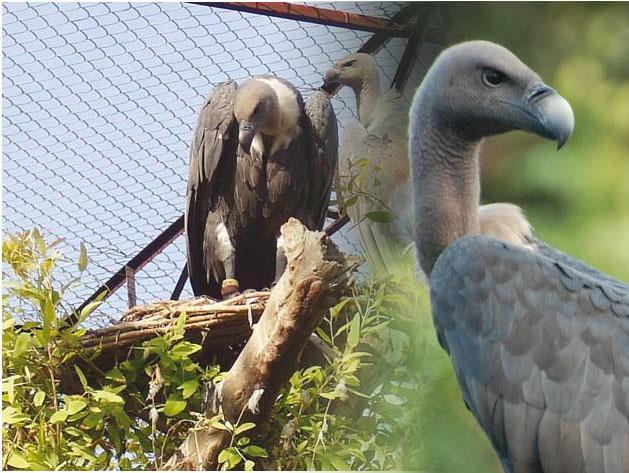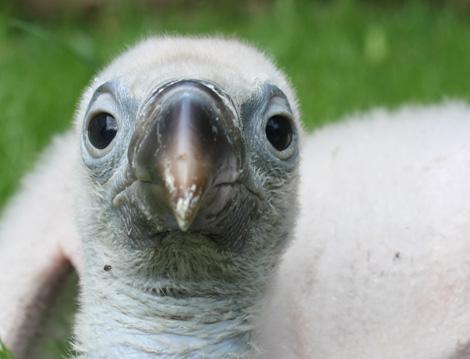The first image is the image on the left, the second image is the image on the right. For the images displayed, is the sentence "The entire bird is visible in the image on the right." factually correct? Answer yes or no. No. 